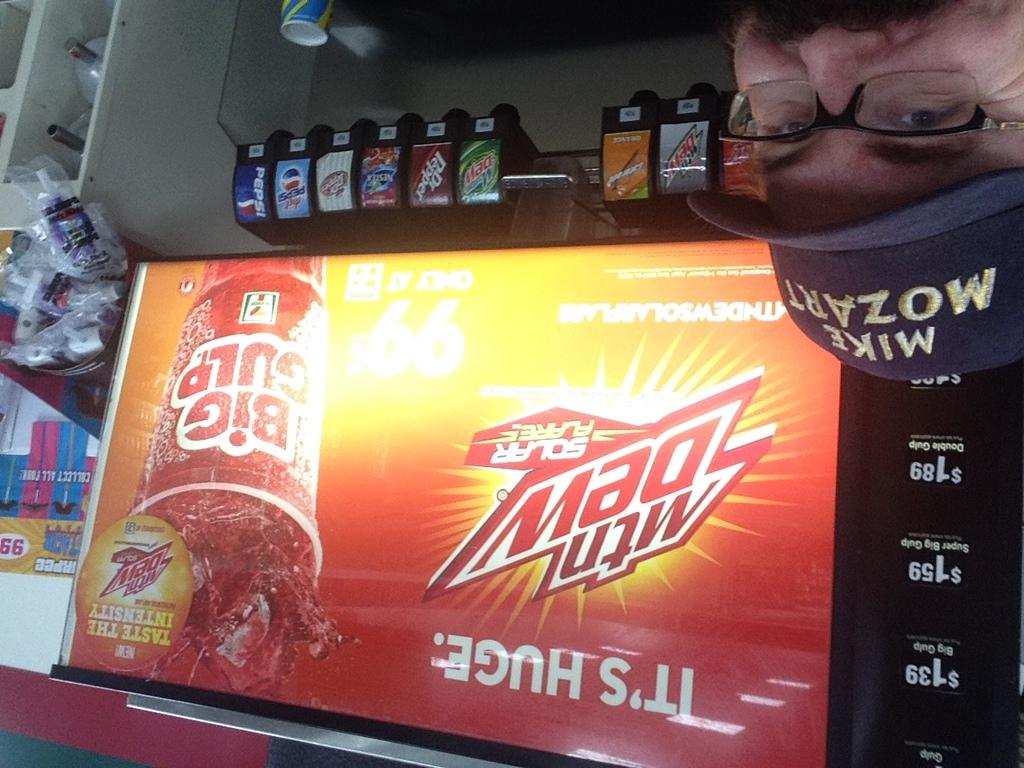<image>
Share a concise interpretation of the image provided. A soda fountain that has an ad for Mountain Dew on it 